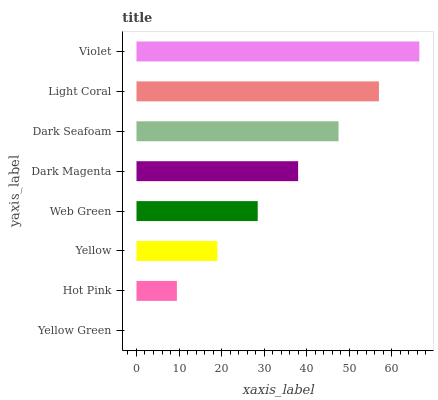Is Yellow Green the minimum?
Answer yes or no. Yes. Is Violet the maximum?
Answer yes or no. Yes. Is Hot Pink the minimum?
Answer yes or no. No. Is Hot Pink the maximum?
Answer yes or no. No. Is Hot Pink greater than Yellow Green?
Answer yes or no. Yes. Is Yellow Green less than Hot Pink?
Answer yes or no. Yes. Is Yellow Green greater than Hot Pink?
Answer yes or no. No. Is Hot Pink less than Yellow Green?
Answer yes or no. No. Is Dark Magenta the high median?
Answer yes or no. Yes. Is Web Green the low median?
Answer yes or no. Yes. Is Web Green the high median?
Answer yes or no. No. Is Yellow Green the low median?
Answer yes or no. No. 